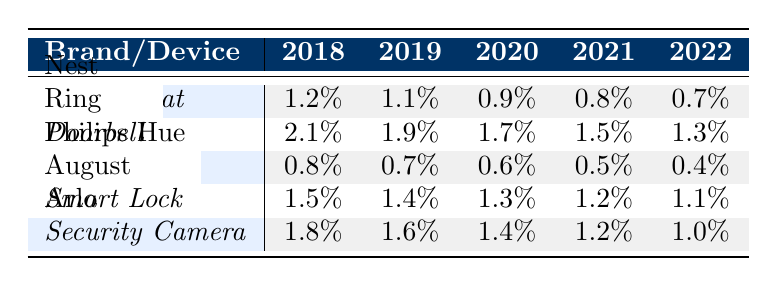What is the failure rate of the Nest thermostat in 2020? According to the table, the specific row for the Nest thermostat in the year 2020 shows a failure rate of 0.9%.
Answer: 0.9% Which brand has the highest failure rate for its device type in 2018? In the year 2018, the failure rate for Ring's doorbell is 2.1%, which is higher than the failure rates of all other brands listed for that year.
Answer: Ring What is the average failure rate of August's smart locks over the 5 years? Adding the failure rates for each year: (1.5 + 1.4 + 1.3 + 1.2 + 1.1) equals 6.5%. Dividing this sum by the number of years (5) gives an average of 1.3%.
Answer: 1.3% Did Philips Hue's smart bulbs have a failure rate above 1% in any year from 2018 to 2022? Referencing the table, the highest failure rate for Philips Hue smart bulbs was 0.8% in 2018, which is below 1%. Therefore, the answer is no.
Answer: No What is the trend of the failure rates for Arlo security cameras from 2018 to 2022? Evaluating the failure rates across the years shows a decreasing trend: 1.8% in 2018, 1.6% in 2019, 1.4% in 2020, 1.2% in 2021, and 1.0% in 2022. This indicates consistent improvement over the years.
Answer: Decreasing What is the difference in failure rates between the Ring doorbell and August smart lock in 2022? The failure rate for Ring doorbell in 2022 is 1.3%, while for August smart lock it is 1.1%. Calculating the difference: 1.3% - 1.1% equals 0.2%.
Answer: 0.2% Which device type from the brands listed showed the most significant improvement in failure rates over the 5 years? Analyzing the trends, the Nest thermostat decreased from 1.2% down to 0.7%, showing a decrease of 0.5%, while the Arlo security camera decreased from 1.8% to 1.0%, showing a decrease of 0.8%. The August smart lock also saw significant improvement but the highest reduction occurs with the Arlo security camera.
Answer: Arlo security camera In what year did Philips Hue attain its lowest failure rate? Looking at the data for Philips Hue, the failure rate decreased year over year from 0.8% in 2018 to 0.4% in 2022, making 2022 the year with the lowest failure rate.
Answer: 2022 Which brand has consistently the lowest failure rates across all years listed? Reviewing all brands, Philips Hue's smart bulbs have the lowest failure rates each year compared to other devices, starting from 0.8% in 2018 down to 0.4% in 2022.
Answer: Philips Hue 